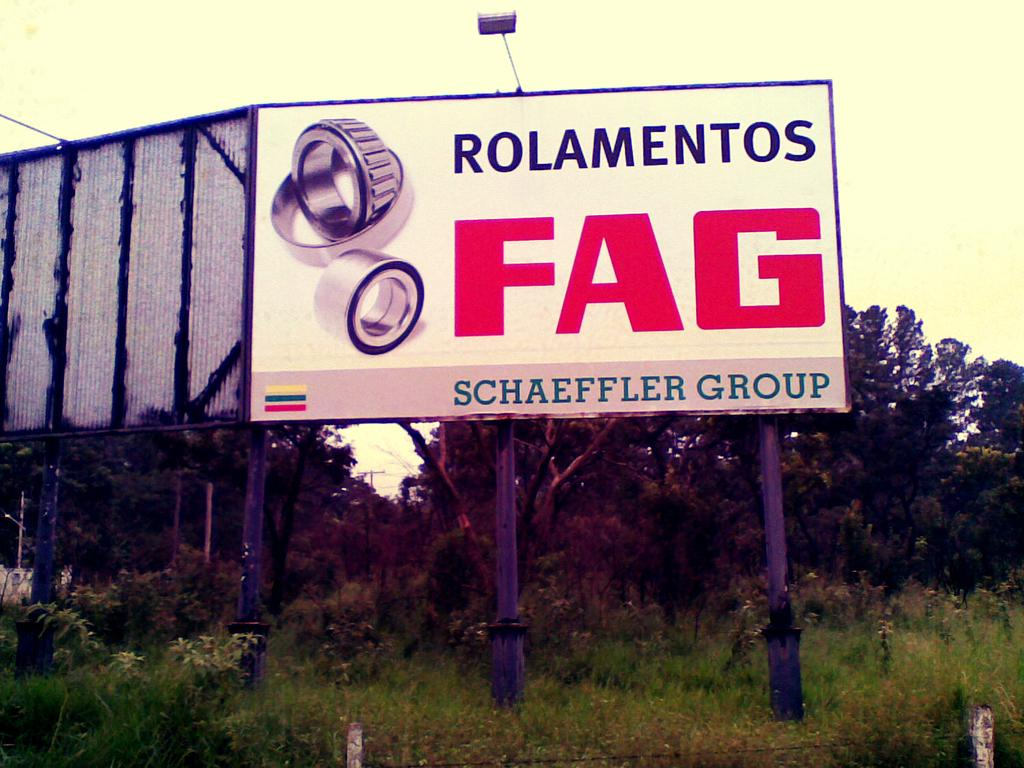<image>
Share a concise interpretation of the image provided. a billboard for Rolamentos FAG in some tall grass 